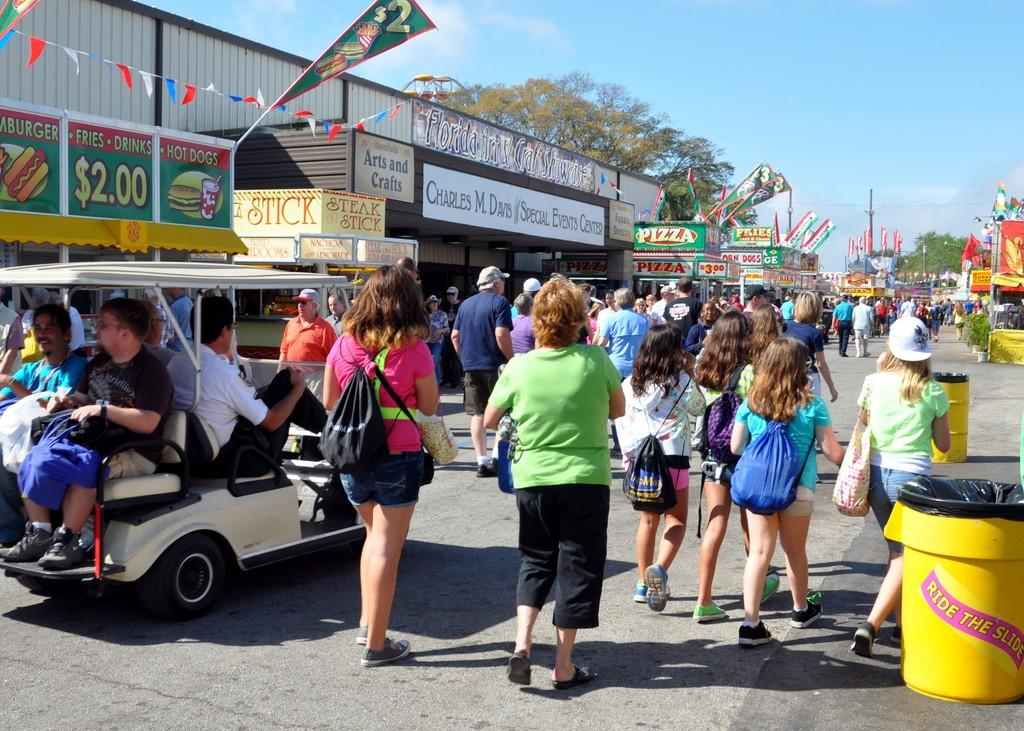What is the main feature of the image? There is a road in the image. What else can be seen on the road? There are vehicles in the image. What is located alongside the road? There are stalls on both sides of the road. What type of vegetation is visible in the image? There are trees in the image. What is visible above the road and stalls? The sky is visible in the image. What is the condition of the top of the stalls in the image? The provided facts do not mention the condition of the top of the stalls, nor is there any information about the top of the stalls in the image. 